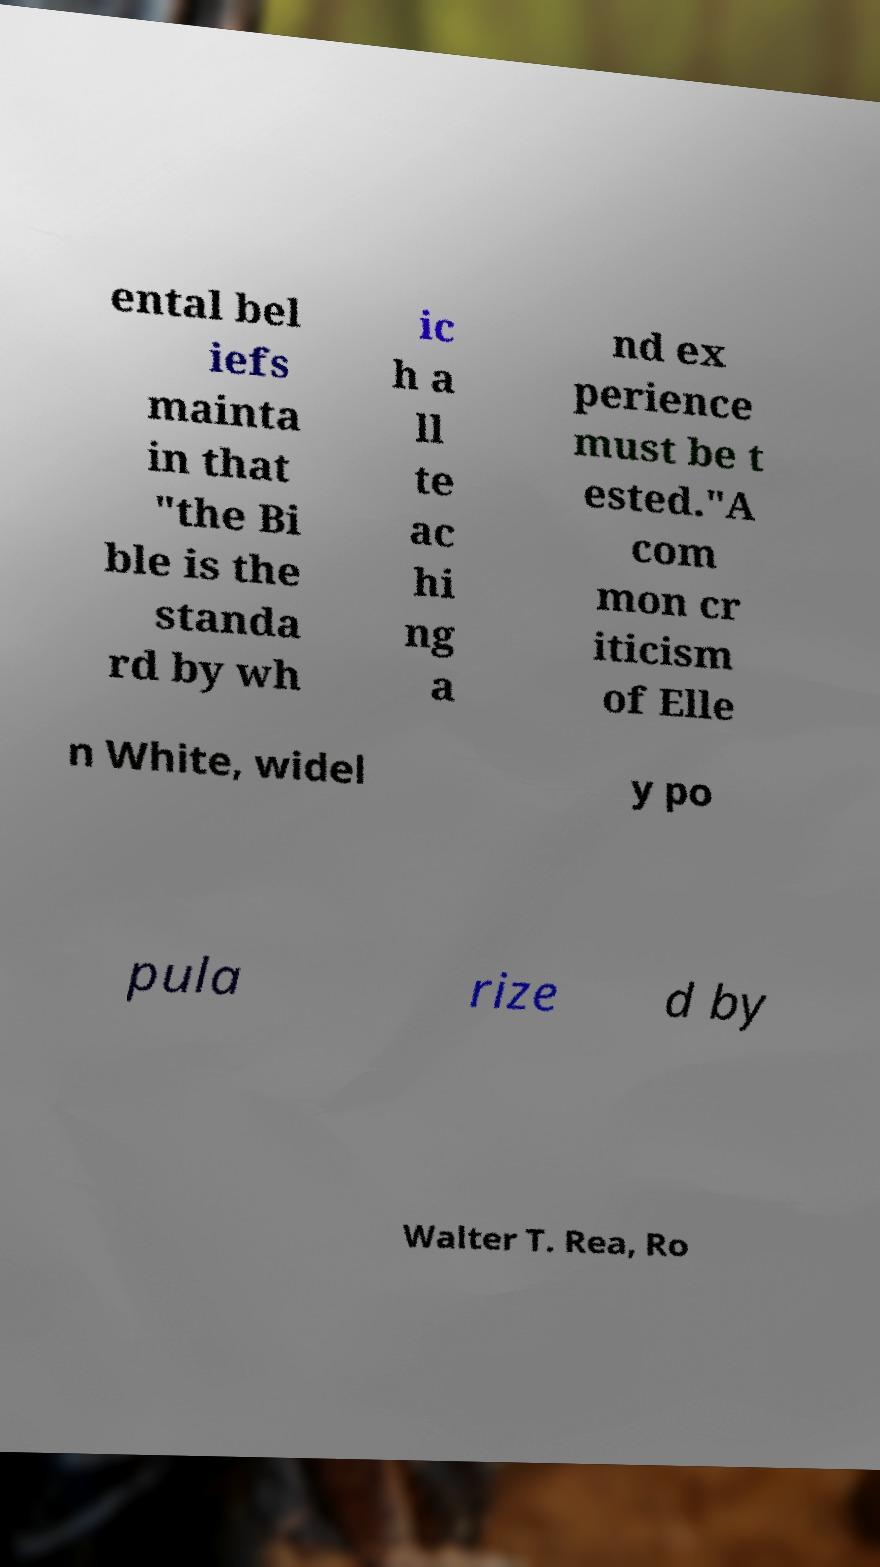Can you accurately transcribe the text from the provided image for me? ental bel iefs mainta in that "the Bi ble is the standa rd by wh ic h a ll te ac hi ng a nd ex perience must be t ested."A com mon cr iticism of Elle n White, widel y po pula rize d by Walter T. Rea, Ro 